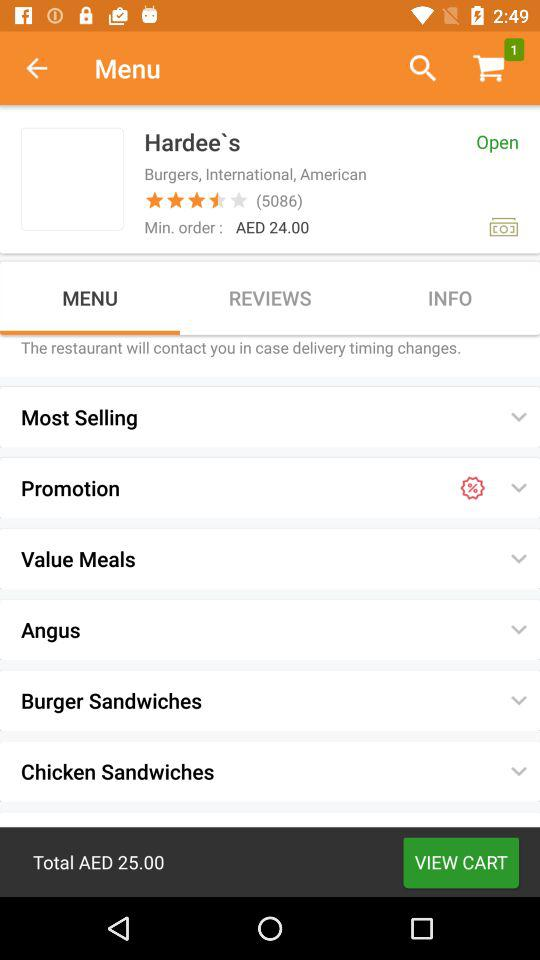How many reviews are there?
When the provided information is insufficient, respond with <no answer>. <no answer> 